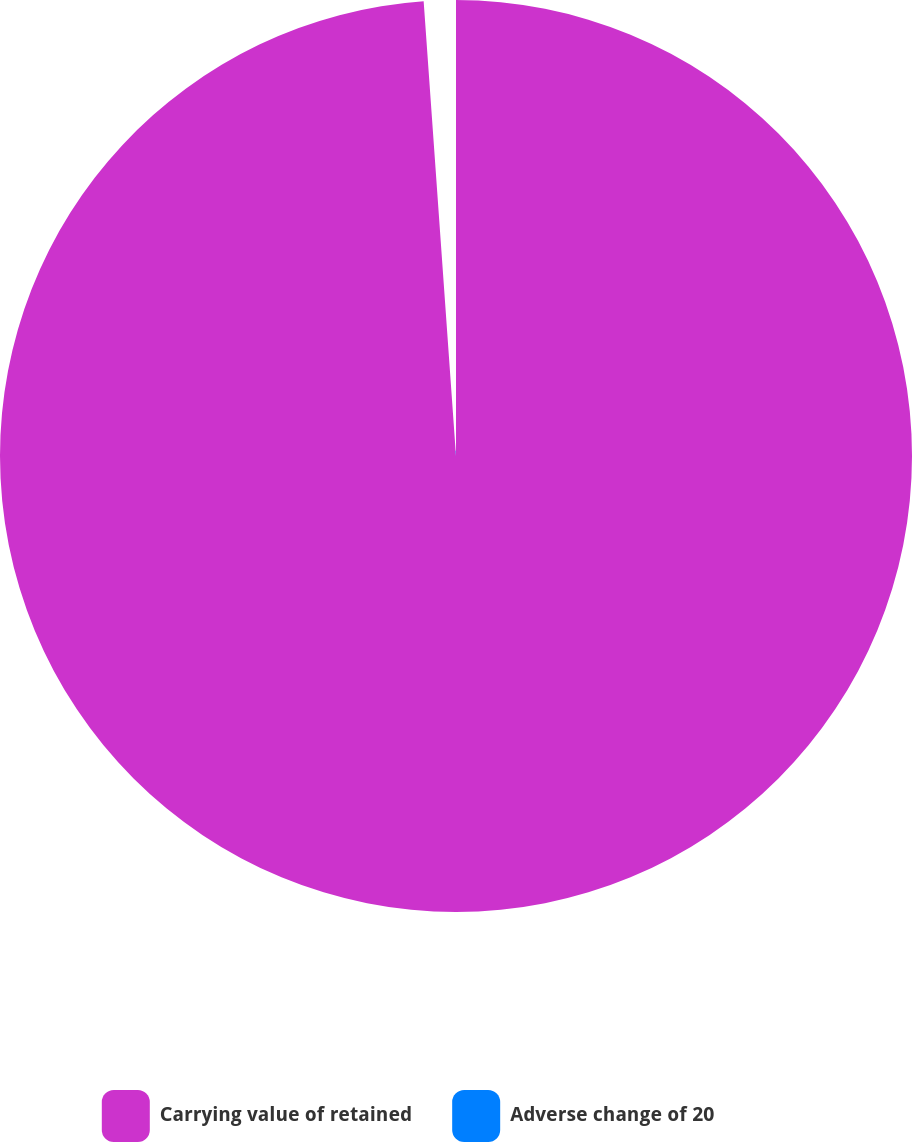Convert chart. <chart><loc_0><loc_0><loc_500><loc_500><pie_chart><fcel>Carrying value of retained<fcel>Adverse change of 20<nl><fcel>98.87%<fcel>1.13%<nl></chart> 